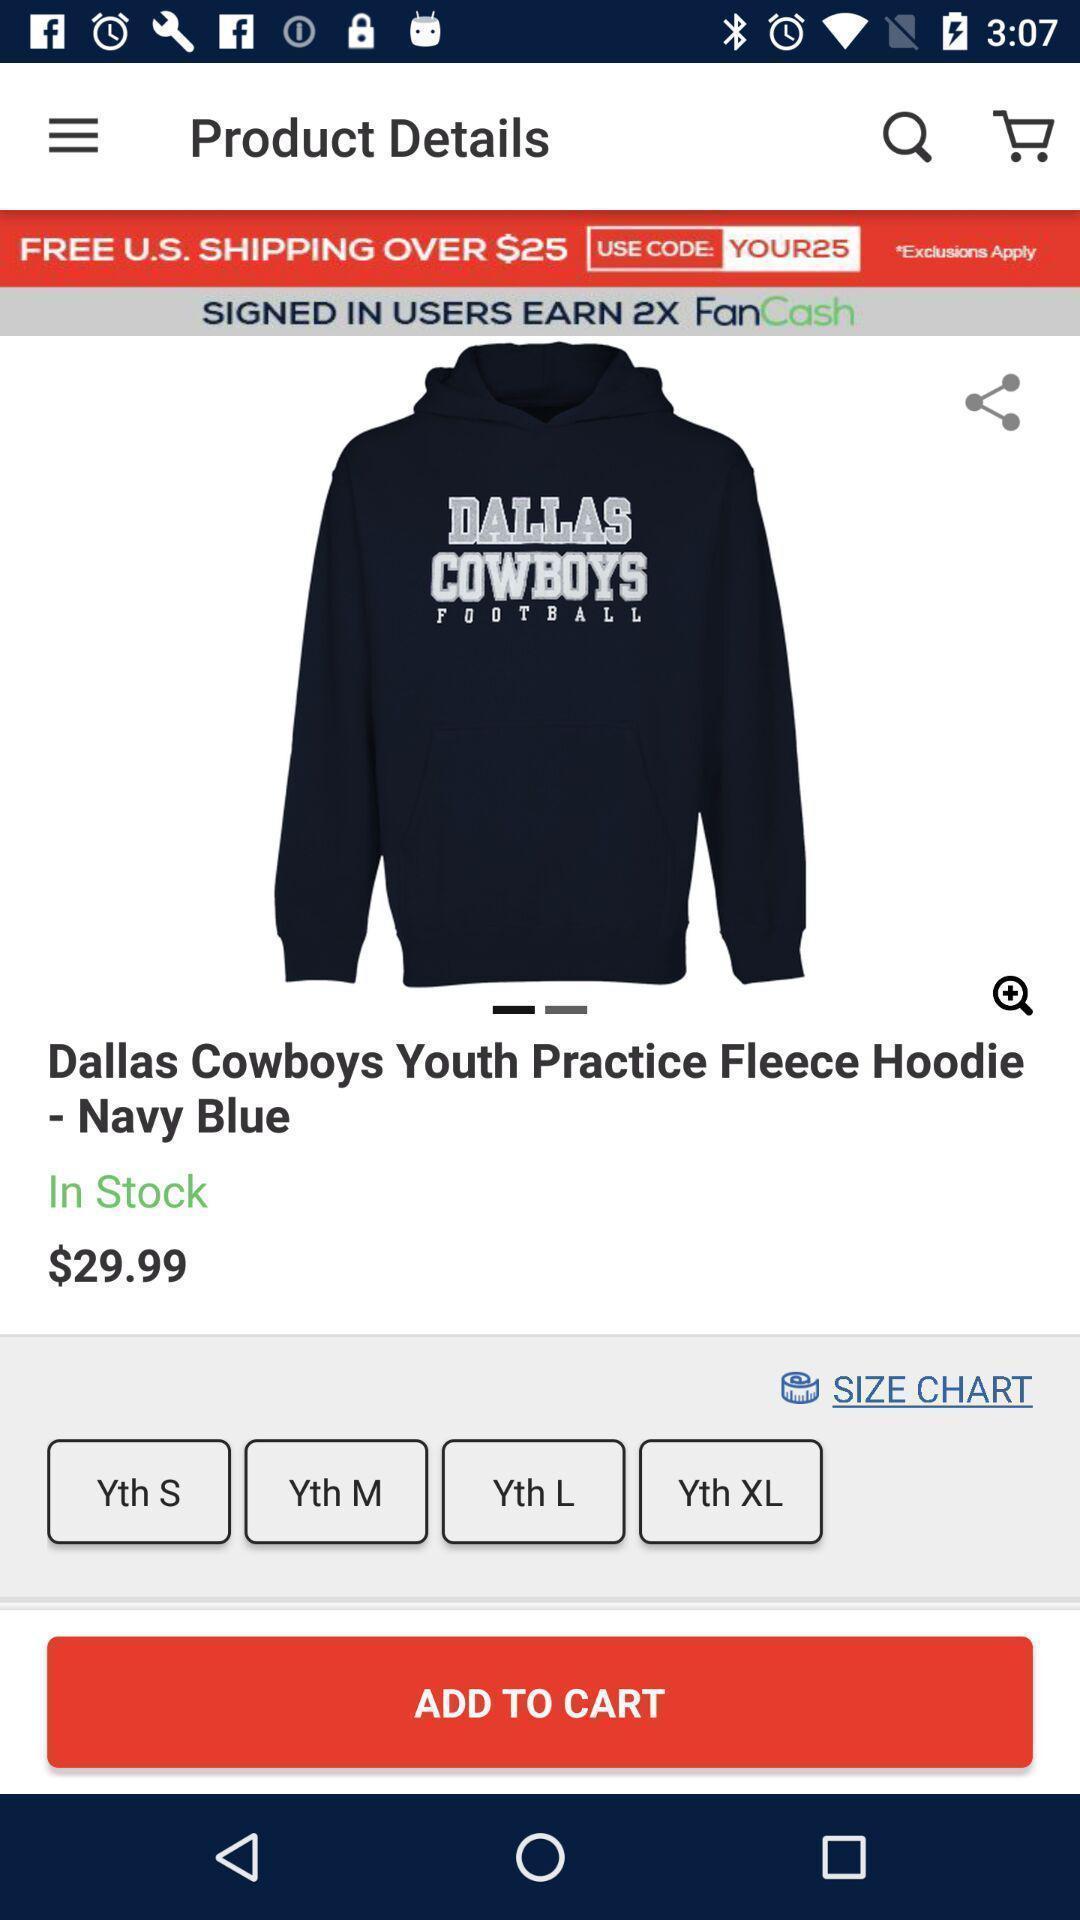Describe this image in words. Screen showing page of an online shopping application. 